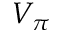<formula> <loc_0><loc_0><loc_500><loc_500>V _ { \pi }</formula> 